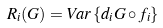Convert formula to latex. <formula><loc_0><loc_0><loc_500><loc_500>R _ { i } ( G ) = V a r \left \{ d _ { i } G \circ f _ { i } \right \}</formula> 